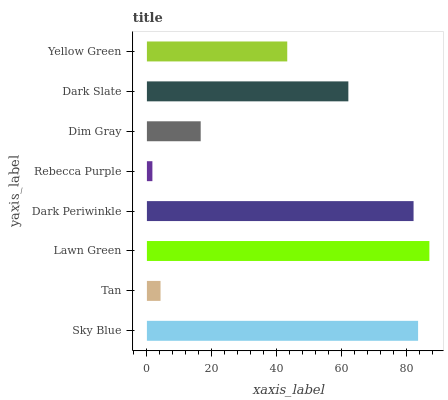Is Rebecca Purple the minimum?
Answer yes or no. Yes. Is Lawn Green the maximum?
Answer yes or no. Yes. Is Tan the minimum?
Answer yes or no. No. Is Tan the maximum?
Answer yes or no. No. Is Sky Blue greater than Tan?
Answer yes or no. Yes. Is Tan less than Sky Blue?
Answer yes or no. Yes. Is Tan greater than Sky Blue?
Answer yes or no. No. Is Sky Blue less than Tan?
Answer yes or no. No. Is Dark Slate the high median?
Answer yes or no. Yes. Is Yellow Green the low median?
Answer yes or no. Yes. Is Yellow Green the high median?
Answer yes or no. No. Is Sky Blue the low median?
Answer yes or no. No. 